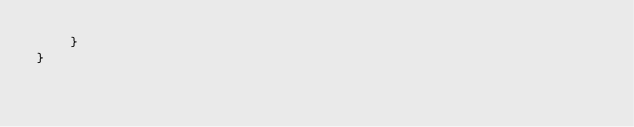<code> <loc_0><loc_0><loc_500><loc_500><_TypeScript_>	}
}
</code> 